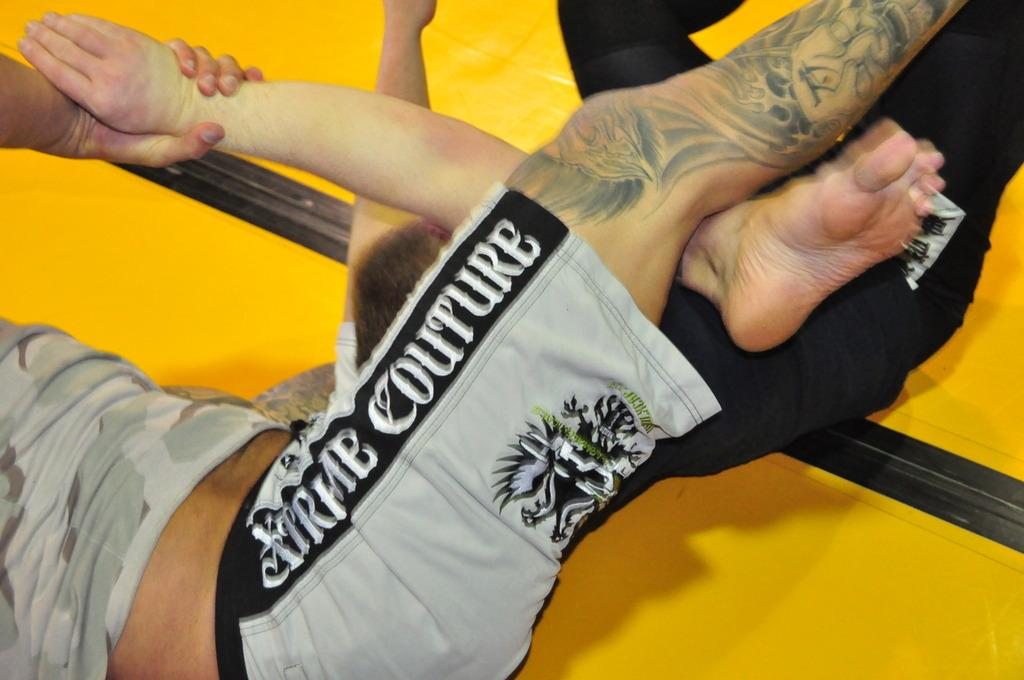Provide a one-sentence caption for the provided image. A pair of shorts that say Extrme Couture on them. 